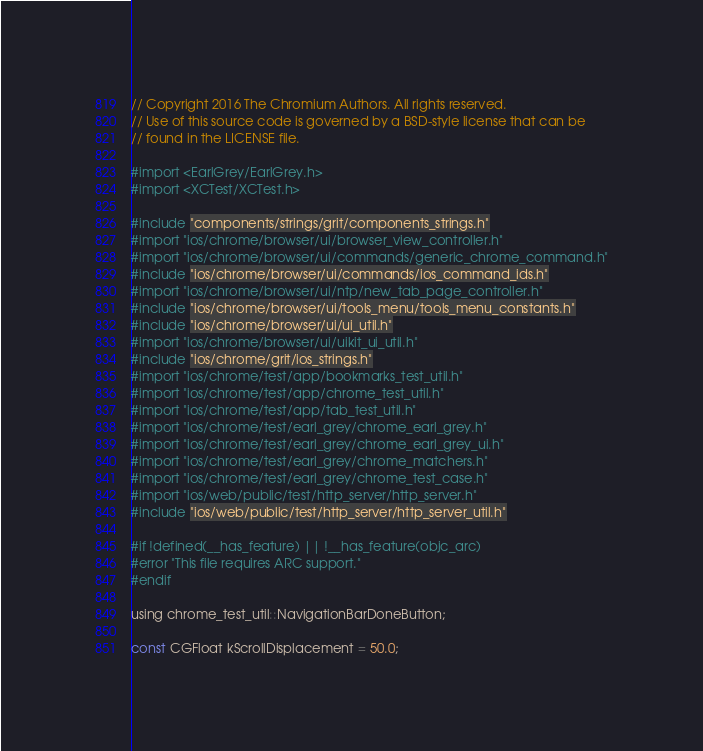<code> <loc_0><loc_0><loc_500><loc_500><_ObjectiveC_>// Copyright 2016 The Chromium Authors. All rights reserved.
// Use of this source code is governed by a BSD-style license that can be
// found in the LICENSE file.

#import <EarlGrey/EarlGrey.h>
#import <XCTest/XCTest.h>

#include "components/strings/grit/components_strings.h"
#import "ios/chrome/browser/ui/browser_view_controller.h"
#import "ios/chrome/browser/ui/commands/generic_chrome_command.h"
#include "ios/chrome/browser/ui/commands/ios_command_ids.h"
#import "ios/chrome/browser/ui/ntp/new_tab_page_controller.h"
#include "ios/chrome/browser/ui/tools_menu/tools_menu_constants.h"
#include "ios/chrome/browser/ui/ui_util.h"
#import "ios/chrome/browser/ui/uikit_ui_util.h"
#include "ios/chrome/grit/ios_strings.h"
#import "ios/chrome/test/app/bookmarks_test_util.h"
#import "ios/chrome/test/app/chrome_test_util.h"
#import "ios/chrome/test/app/tab_test_util.h"
#import "ios/chrome/test/earl_grey/chrome_earl_grey.h"
#import "ios/chrome/test/earl_grey/chrome_earl_grey_ui.h"
#import "ios/chrome/test/earl_grey/chrome_matchers.h"
#import "ios/chrome/test/earl_grey/chrome_test_case.h"
#import "ios/web/public/test/http_server/http_server.h"
#include "ios/web/public/test/http_server/http_server_util.h"

#if !defined(__has_feature) || !__has_feature(objc_arc)
#error "This file requires ARC support."
#endif

using chrome_test_util::NavigationBarDoneButton;

const CGFloat kScrollDisplacement = 50.0;
</code> 